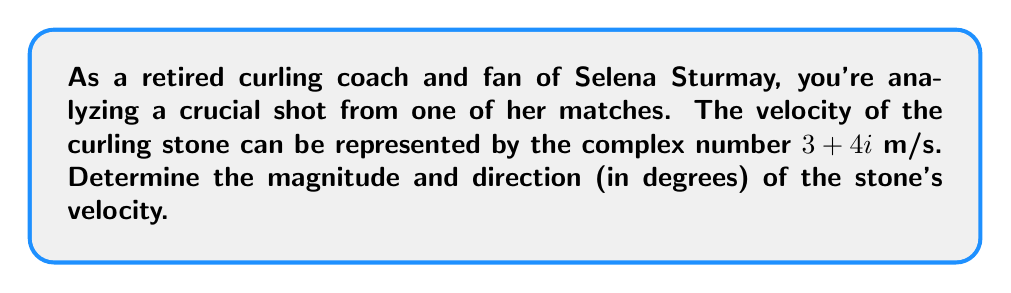Give your solution to this math problem. To solve this problem, we'll use complex number properties:

1. Magnitude calculation:
   The magnitude of a complex number $a + bi$ is given by $\sqrt{a^2 + b^2}$.
   In this case, $a = 3$ and $b = 4$.
   
   $$|3 + 4i| = \sqrt{3^2 + 4^2} = \sqrt{9 + 16} = \sqrt{25} = 5\text{ m/s}$$

2. Direction calculation:
   The direction is the angle the velocity vector makes with the positive real axis.
   We can calculate this using the arctangent function:
   
   $$\theta = \tan^{-1}\left(\frac{\text{imaginary part}}{\text{real part}}\right) = \tan^{-1}\left(\frac{4}{3}\right)$$
   
   Using a calculator or trigonometric tables:
   
   $$\theta = \tan^{-1}\left(\frac{4}{3}\right) \approx 53.13^\circ$$

Therefore, the curling stone's velocity has a magnitude of 5 m/s and a direction of approximately 53.13° counterclockwise from the positive real axis.
Answer: Magnitude: 5 m/s
Direction: 53.13° 